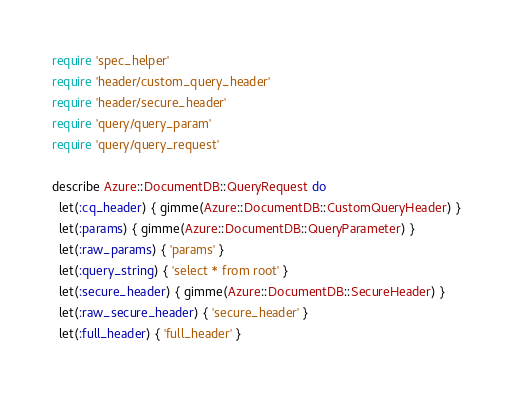<code> <loc_0><loc_0><loc_500><loc_500><_Ruby_>require 'spec_helper'
require 'header/custom_query_header'
require 'header/secure_header'
require 'query/query_param'
require 'query/query_request'

describe Azure::DocumentDB::QueryRequest do
  let(:cq_header) { gimme(Azure::DocumentDB::CustomQueryHeader) }
  let(:params) { gimme(Azure::DocumentDB::QueryParameter) }
  let(:raw_params) { 'params' }
  let(:query_string) { 'select * from root' }
  let(:secure_header) { gimme(Azure::DocumentDB::SecureHeader) }
  let(:raw_secure_header) { 'secure_header' }
  let(:full_header) { 'full_header' }</code> 